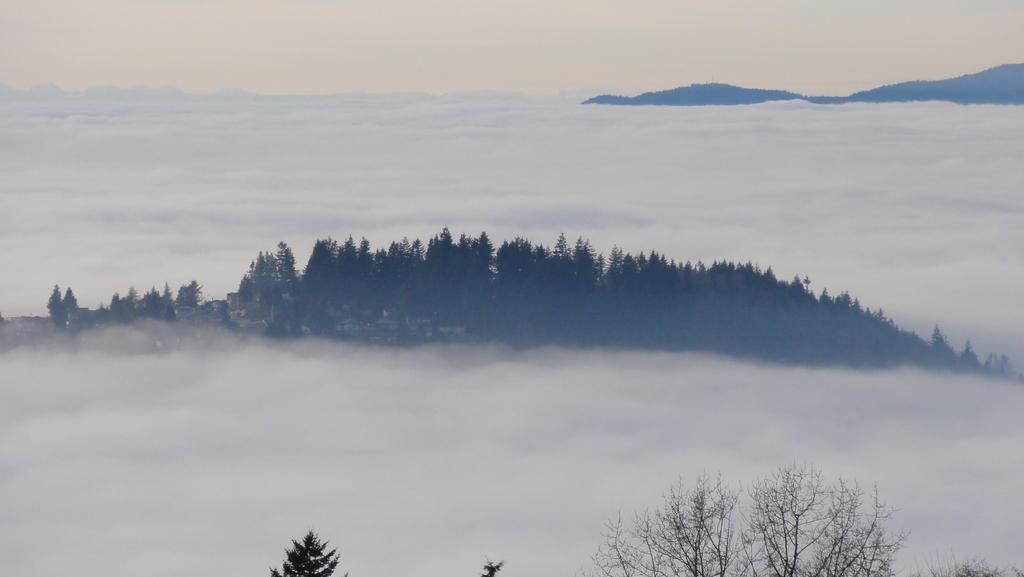What can be seen in the background of the image? The sky is visible in the image. What type of landscape feature is present in the image? There are hills in the image. What type of vegetation is present in the image? Trees are present in the image. What atmospheric condition can be observed in the image? There is fog in the image. What type of noise can be heard coming from the cave in the image? There is no cave present in the image, so it is not possible to determine what, if any, noise might be heard. 